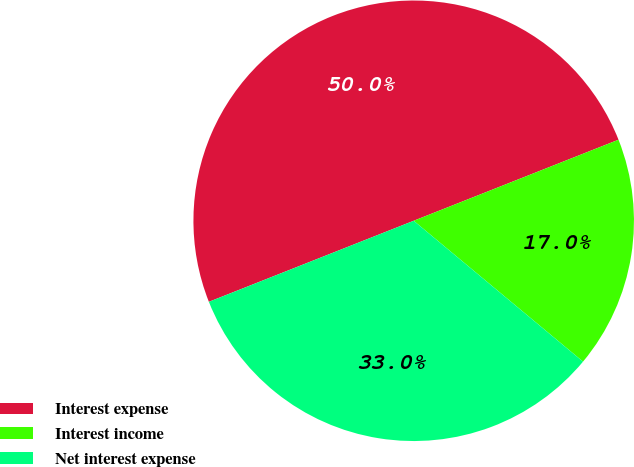<chart> <loc_0><loc_0><loc_500><loc_500><pie_chart><fcel>Interest expense<fcel>Interest income<fcel>Net interest expense<nl><fcel>50.0%<fcel>17.04%<fcel>32.96%<nl></chart> 